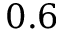<formula> <loc_0><loc_0><loc_500><loc_500>0 . 6</formula> 